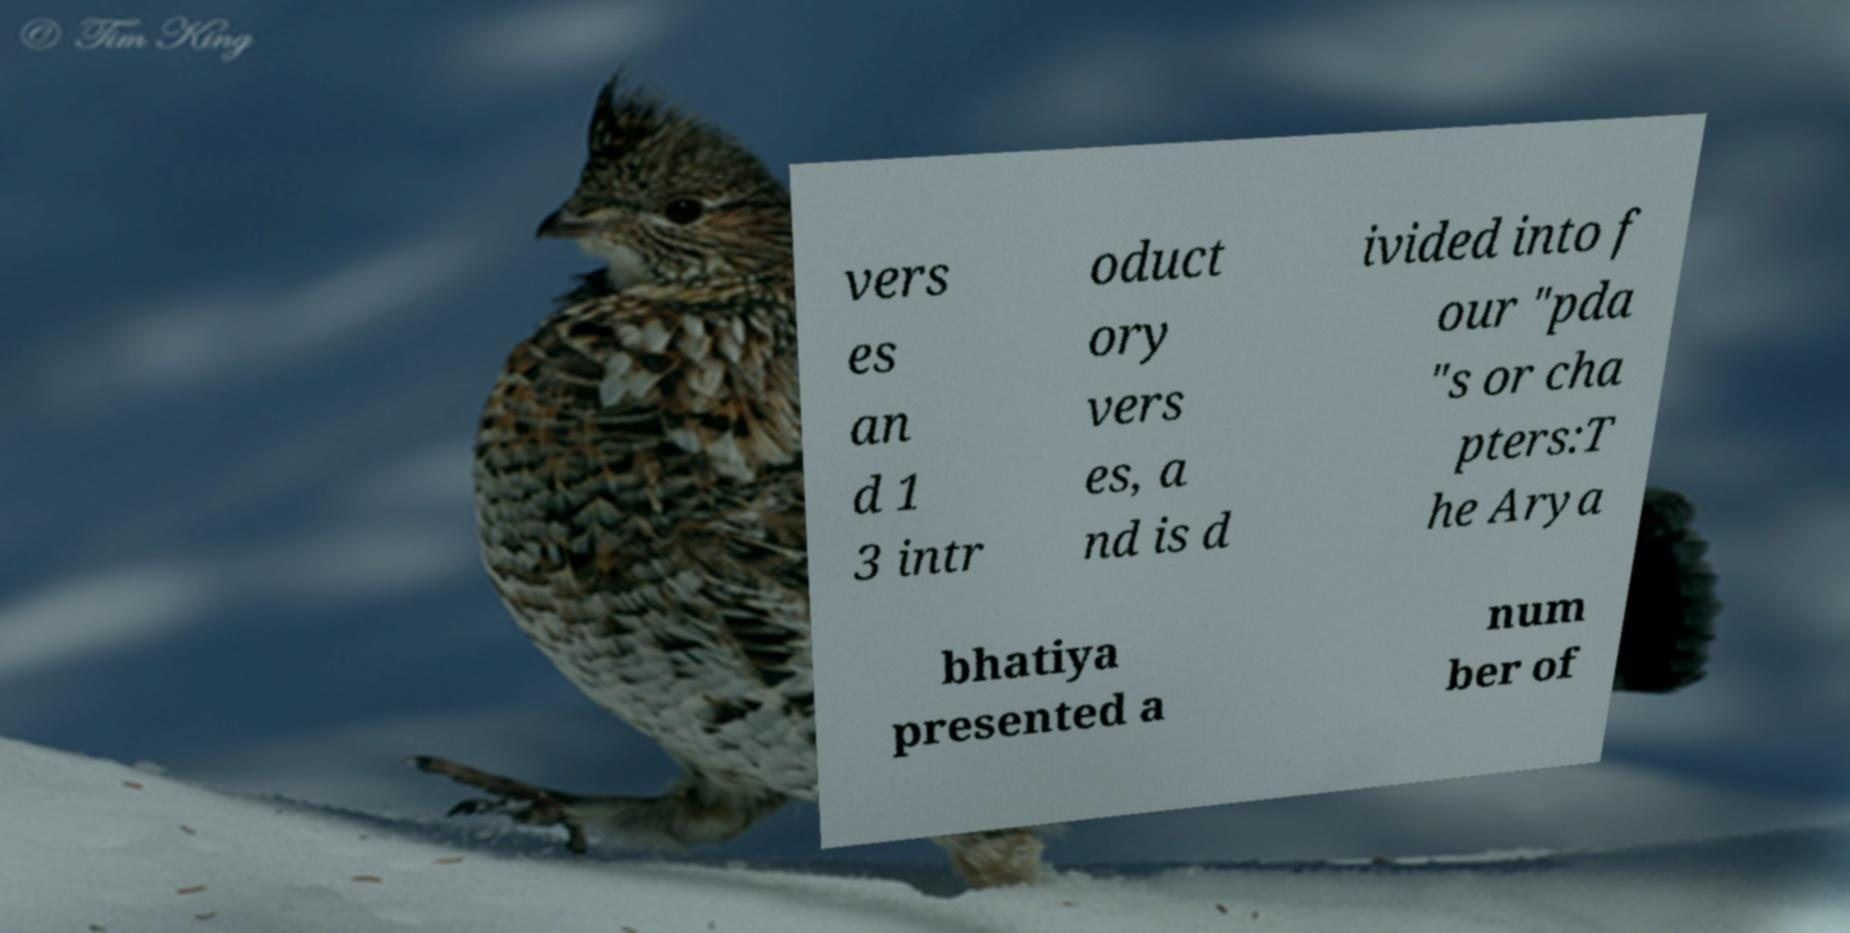Please read and relay the text visible in this image. What does it say? vers es an d 1 3 intr oduct ory vers es, a nd is d ivided into f our "pda "s or cha pters:T he Arya bhatiya presented a num ber of 